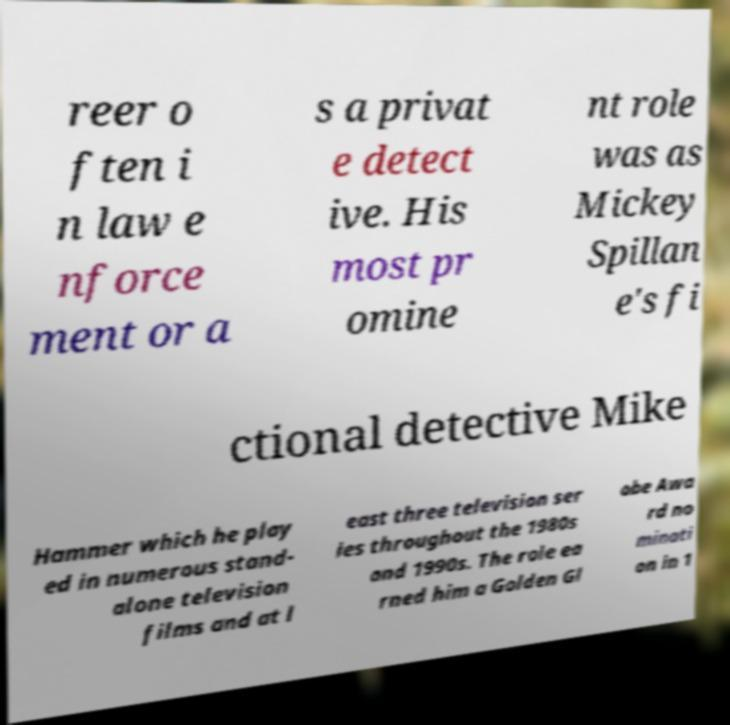Could you extract and type out the text from this image? reer o ften i n law e nforce ment or a s a privat e detect ive. His most pr omine nt role was as Mickey Spillan e's fi ctional detective Mike Hammer which he play ed in numerous stand- alone television films and at l east three television ser ies throughout the 1980s and 1990s. The role ea rned him a Golden Gl obe Awa rd no minati on in 1 